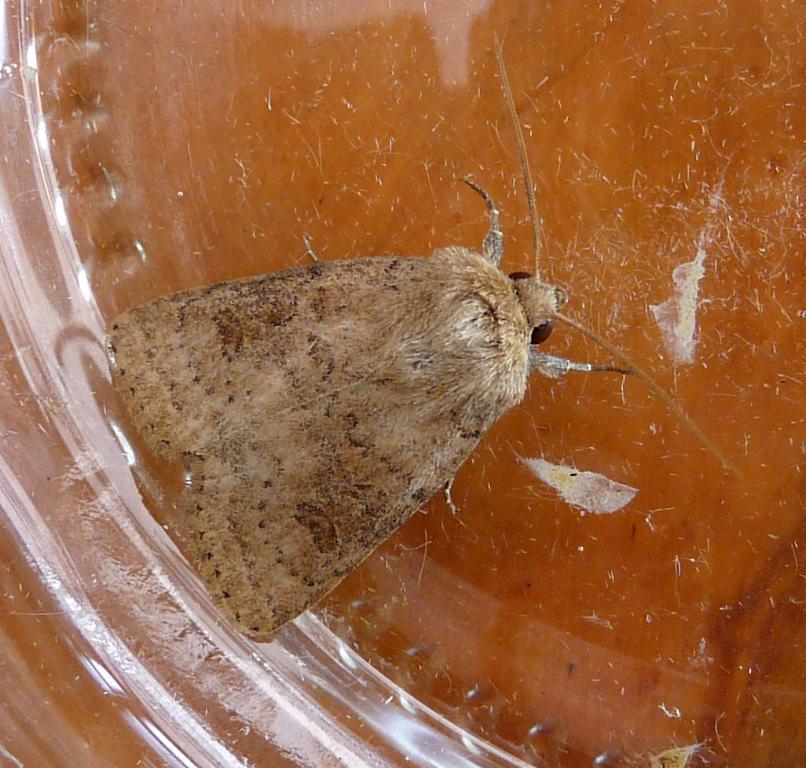Please provide a concise description of this image. In this picture I can observe an insect in the middle of the picture. This insect is in brown color. 